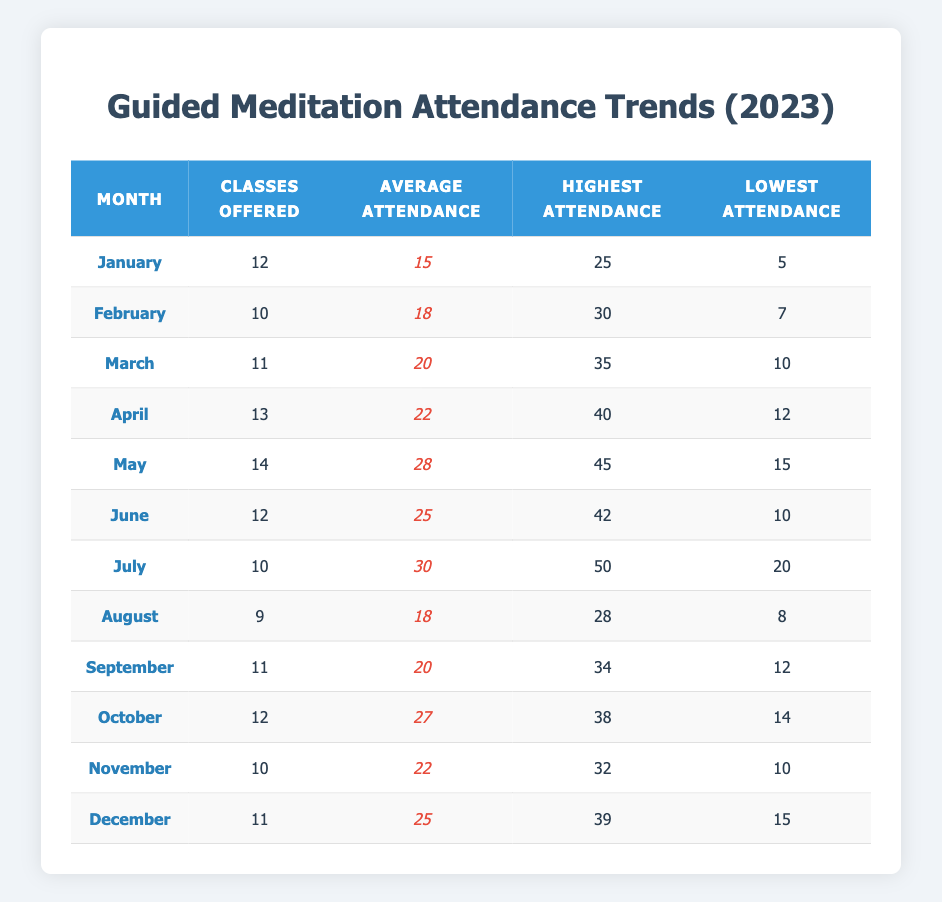What was the average attendance in May? In the table, the average attendance for May is highlighted and listed under the Average Attendance column. The data shows that the average attendance in May is 28.
Answer: 28 Which month had the highest attendance overall? The highest attendance for each month is given in the Highest Attendance column. Looking through the data, July has the highest attendance of 50.
Answer: 50 How many classes were offered in April? Referring to the Classes Offered column, the number of classes offered in April is specified, which is 13.
Answer: 13 What is the difference between the highest and lowest attendance in February? In February, the highest attendance is 30 and the lowest attendance is 7. The difference is calculated as 30 - 7 = 23.
Answer: 23 Did November have an average attendance greater than 20? The average attendance in November is listed in the table as 22. Since 22 is greater than 20, the statement is true.
Answer: Yes What is the average attendance for the second half of the year (July to December)? The average attendance for the second half is calculated by adding the average attendances from July (30), August (18), September (20), October (27), November (22), and December (25) which totals 142. There are 6 months, so 142/6 gives an average of 23.67.
Answer: 23.67 Which month had the lowest average attendance? The average attendances for each month are compared, and February (18) has the lowest average attendance in the list.
Answer: 18 What was the highest attendance recorded in October? According to the table, the highest attendance in October is specified in the Highest Attendance column as 38.
Answer: 38 How many classes were offered in the months with an average attendance above 25? From the months with average attendance above 25, only May (14), July (10), and October (12) qualify. Therefore, the total classes offered is 14 + 10 + 12 = 36.
Answer: 36 Is the average attendance in December lower than in April? The average attendance for December is 25 and for April, it is 22. Since 25 is not lower than 22, the statement is false.
Answer: No 